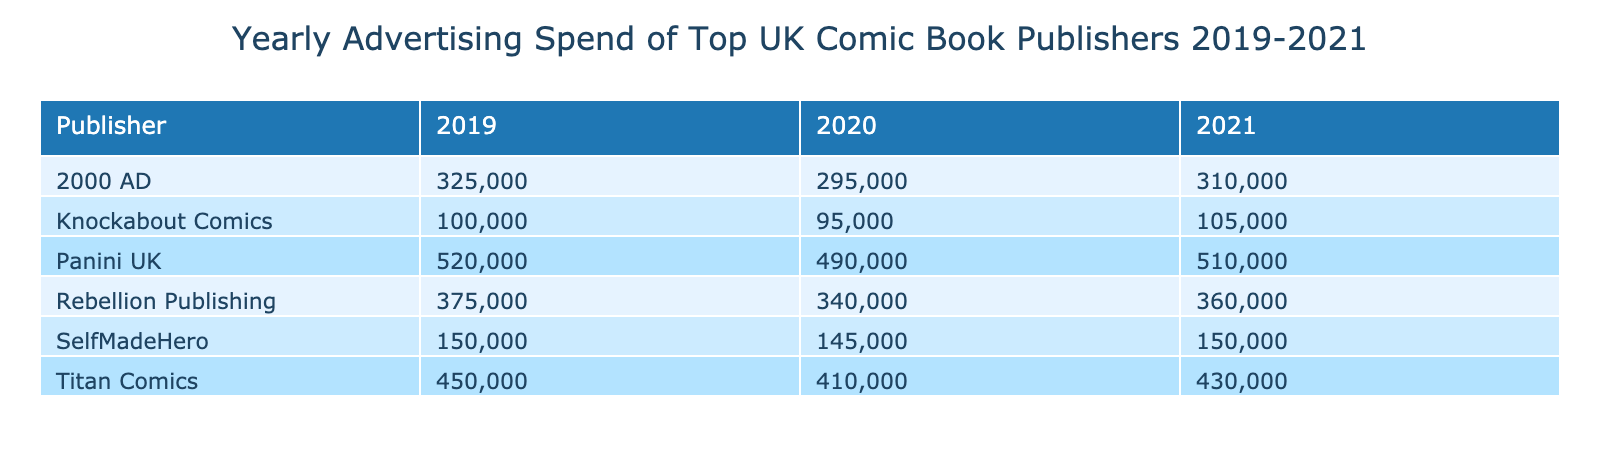What was the advertising spend of Titan Comics in 2020? In the table, we look for the row corresponding to Titan Comics and the year 2020. Under the column 'Advertising Spend (GBP)', the value is 410000.
Answer: 410000 What is the total advertising spend of Panini UK across 2019 to 2021? First, we identify the advertising spends for Panini UK in each year: 520000 (2019), 490000 (2020), and 510000 (2021). Next, we sum these values: 520000 + 490000 + 510000 = 1520000.
Answer: 1520000 Did 2000 AD's advertising spend increase from 2020 to 2021? We check the spending for 2000 AD in 2020, which is 295000, and in 2021, which is 310000. Since 310000 is greater than 295000, it indicates an increase.
Answer: Yes What was the average advertising spend of Rebellion Publishing over the three years? We first find the advertising spends for Rebellion Publishing: 375000 (2019), 340000 (2020), and 360000 (2021). Next, we calculate the average: (375000 + 340000 + 360000) / 3 = 375000.
Answer: 375000 Which publisher had the lowest advertising spend in 2021? In the 2021 column of the table, we compare the advertising spends among all publishers. The smallest value is 105000, which corresponds to Knockabout Comics.
Answer: Knockabout Comics What was the change in advertising spend for SelfMadeHero from 2019 to 2021? The spend for SelfMadeHero in 2019 was 150000, and in 2021 it remained the same at 150000. The change is calculated as 150000 - 150000 = 0, indicating no change.
Answer: No change How much more did Titan Comics spend on advertising compared to 2000 AD in 2020? The advertising spend for Titan Comics in 2020 was 410000, and for 2000 AD it was 295000. The difference is calculated as 410000 - 295000 = 115000.
Answer: 115000 What is the total advertising spend of all publishers in 2019? We need to sum up the advertising spend for each publisher in the year 2019: Titan Comics (450000), Rebellion Publishing (375000), Panini UK (520000), 2000 AD (325000), SelfMadeHero (150000), and Knockabout Comics (100000). Adding these gives 450000 + 375000 + 520000 + 325000 + 150000 + 100000 = 1875000.
Answer: 1875000 Which publisher had the highest advertising spend in 2020, and what was the amount? Looking at the advertising spends for 2020, Panini UK had the highest spend of 490000. We confirm by checking all entries for that year.
Answer: Panini UK, 490000 